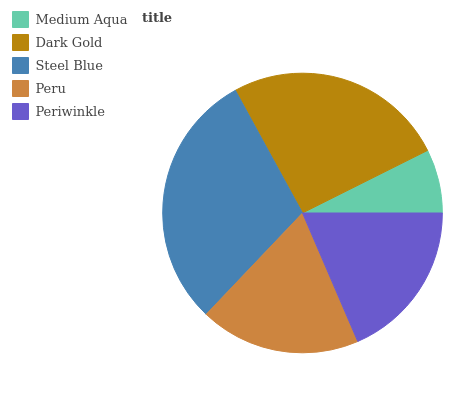Is Medium Aqua the minimum?
Answer yes or no. Yes. Is Steel Blue the maximum?
Answer yes or no. Yes. Is Dark Gold the minimum?
Answer yes or no. No. Is Dark Gold the maximum?
Answer yes or no. No. Is Dark Gold greater than Medium Aqua?
Answer yes or no. Yes. Is Medium Aqua less than Dark Gold?
Answer yes or no. Yes. Is Medium Aqua greater than Dark Gold?
Answer yes or no. No. Is Dark Gold less than Medium Aqua?
Answer yes or no. No. Is Peru the high median?
Answer yes or no. Yes. Is Peru the low median?
Answer yes or no. Yes. Is Medium Aqua the high median?
Answer yes or no. No. Is Dark Gold the low median?
Answer yes or no. No. 